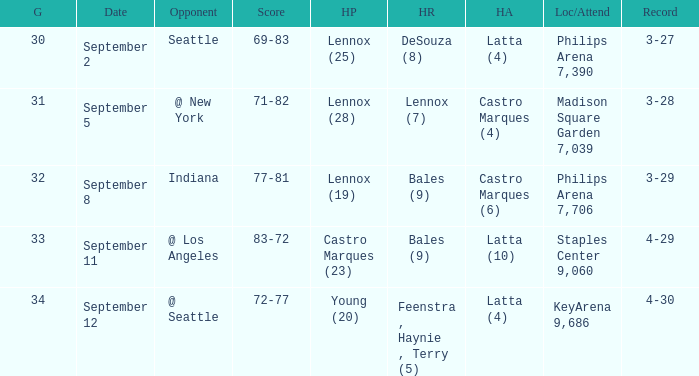What were the high rebounds on september 11? Bales (9). 